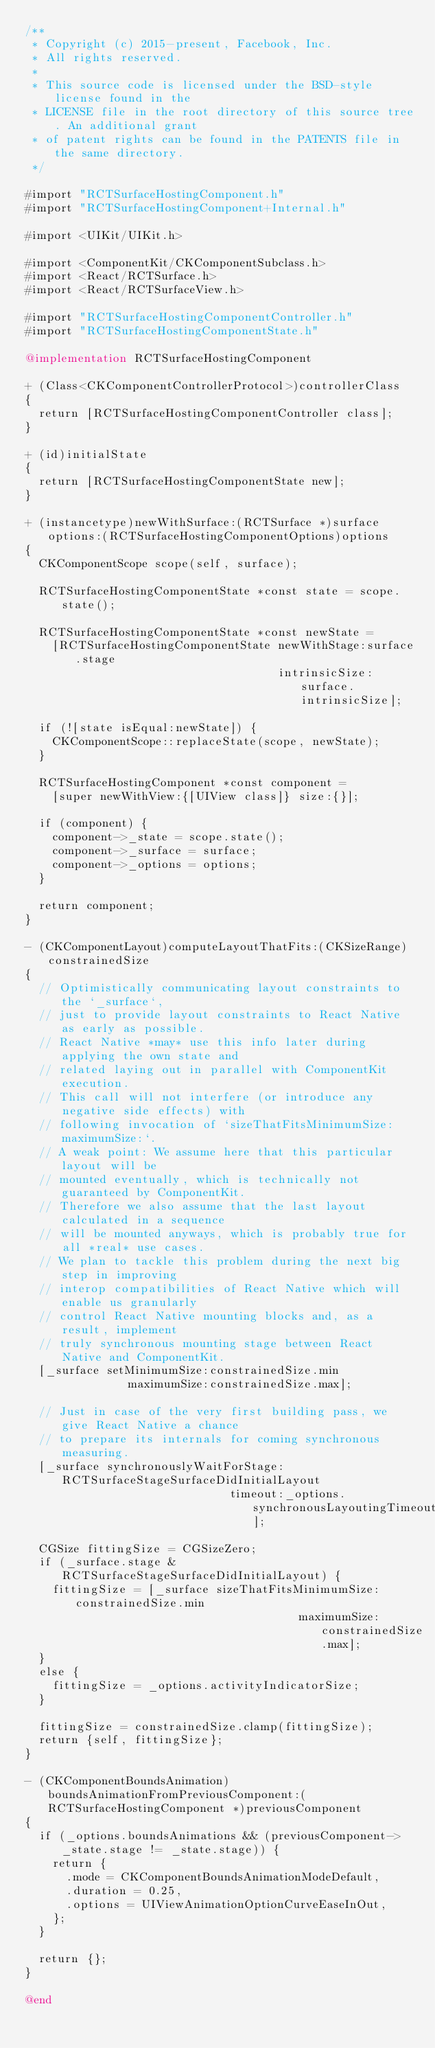Convert code to text. <code><loc_0><loc_0><loc_500><loc_500><_ObjectiveC_>/**
 * Copyright (c) 2015-present, Facebook, Inc.
 * All rights reserved.
 *
 * This source code is licensed under the BSD-style license found in the
 * LICENSE file in the root directory of this source tree. An additional grant
 * of patent rights can be found in the PATENTS file in the same directory.
 */

#import "RCTSurfaceHostingComponent.h"
#import "RCTSurfaceHostingComponent+Internal.h"

#import <UIKit/UIKit.h>

#import <ComponentKit/CKComponentSubclass.h>
#import <React/RCTSurface.h>
#import <React/RCTSurfaceView.h>

#import "RCTSurfaceHostingComponentController.h"
#import "RCTSurfaceHostingComponentState.h"

@implementation RCTSurfaceHostingComponent

+ (Class<CKComponentControllerProtocol>)controllerClass
{
  return [RCTSurfaceHostingComponentController class];
}

+ (id)initialState
{
  return [RCTSurfaceHostingComponentState new];
}

+ (instancetype)newWithSurface:(RCTSurface *)surface options:(RCTSurfaceHostingComponentOptions)options
{
  CKComponentScope scope(self, surface);

  RCTSurfaceHostingComponentState *const state = scope.state();

  RCTSurfaceHostingComponentState *const newState =
    [RCTSurfaceHostingComponentState newWithStage:surface.stage
                                     intrinsicSize:surface.intrinsicSize];

  if (![state isEqual:newState]) {
    CKComponentScope::replaceState(scope, newState);
  }

  RCTSurfaceHostingComponent *const component =
    [super newWithView:{[UIView class]} size:{}];

  if (component) {
    component->_state = scope.state();
    component->_surface = surface;
    component->_options = options;
  }

  return component;
}

- (CKComponentLayout)computeLayoutThatFits:(CKSizeRange)constrainedSize
{
  // Optimistically communicating layout constraints to the `_surface`,
  // just to provide layout constraints to React Native as early as possible.
  // React Native *may* use this info later during applying the own state and
  // related laying out in parallel with ComponentKit execution.
  // This call will not interfere (or introduce any negative side effects) with
  // following invocation of `sizeThatFitsMinimumSize:maximumSize:`.
  // A weak point: We assume here that this particular layout will be
  // mounted eventually, which is technically not guaranteed by ComponentKit.
  // Therefore we also assume that the last layout calculated in a sequence
  // will be mounted anyways, which is probably true for all *real* use cases.
  // We plan to tackle this problem during the next big step in improving
  // interop compatibilities of React Native which will enable us granularly
  // control React Native mounting blocks and, as a result, implement
  // truly synchronous mounting stage between React Native and ComponentKit.
  [_surface setMinimumSize:constrainedSize.min
               maximumSize:constrainedSize.max];

  // Just in case of the very first building pass, we give React Native a chance
  // to prepare its internals for coming synchronous measuring.
  [_surface synchronouslyWaitForStage:RCTSurfaceStageSurfaceDidInitialLayout
                              timeout:_options.synchronousLayoutingTimeout];

  CGSize fittingSize = CGSizeZero;
  if (_surface.stage & RCTSurfaceStageSurfaceDidInitialLayout) {
    fittingSize = [_surface sizeThatFitsMinimumSize:constrainedSize.min
                                        maximumSize:constrainedSize.max];
  }
  else {
    fittingSize = _options.activityIndicatorSize;
  }

  fittingSize = constrainedSize.clamp(fittingSize);
  return {self, fittingSize};
}

- (CKComponentBoundsAnimation)boundsAnimationFromPreviousComponent:(RCTSurfaceHostingComponent *)previousComponent
{
  if (_options.boundsAnimations && (previousComponent->_state.stage != _state.stage)) {
    return {
      .mode = CKComponentBoundsAnimationModeDefault,
      .duration = 0.25,
      .options = UIViewAnimationOptionCurveEaseInOut,
    };
  }

  return {};
}

@end
</code> 